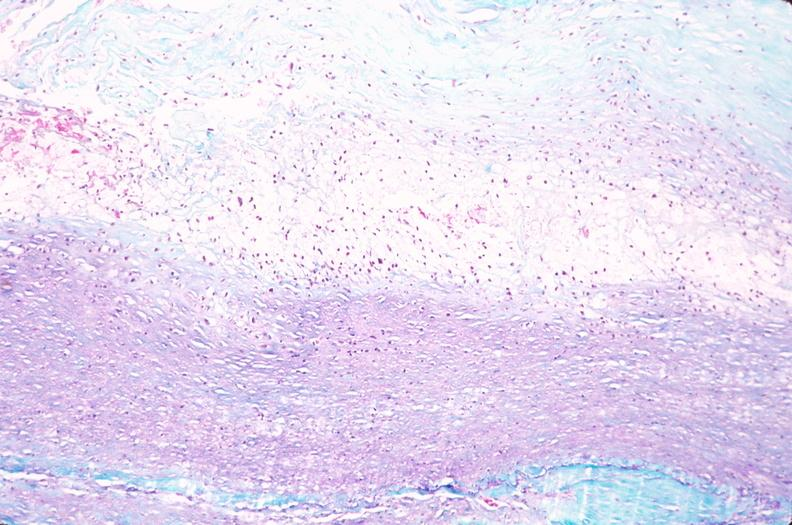does this image show saphenous vein graft sclerosis?
Answer the question using a single word or phrase. Yes 